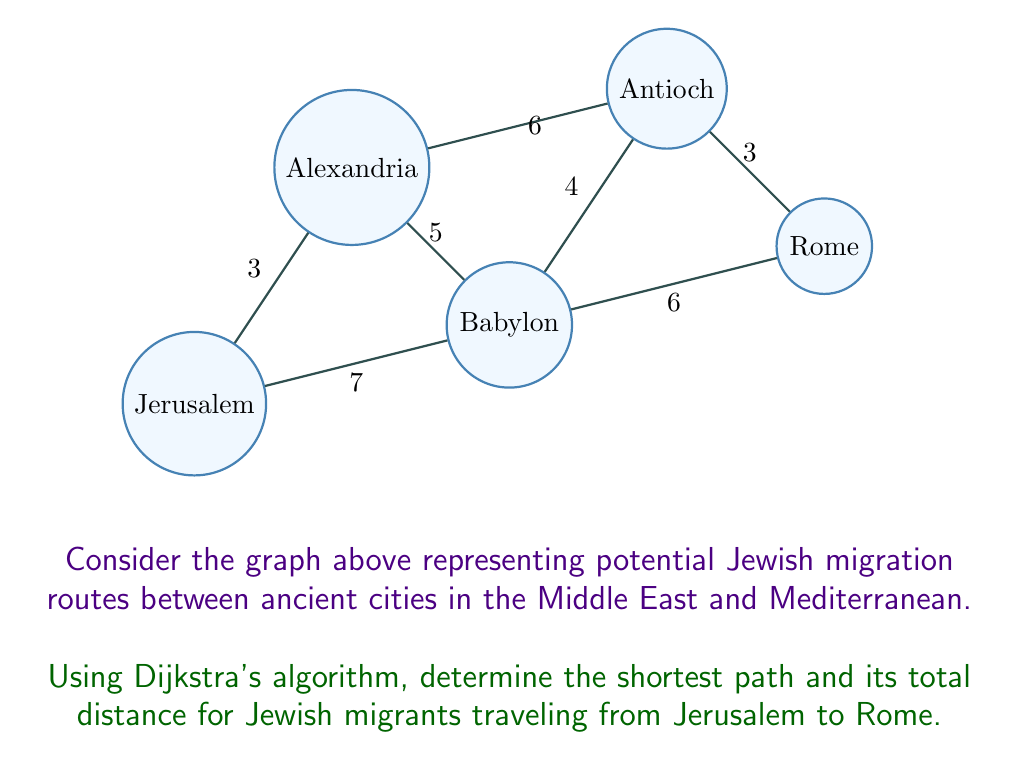Teach me how to tackle this problem. To solve this problem using Dijkstra's algorithm, we'll follow these steps:

1) Initialize:
   - Set distance to Jerusalem (start) as 0
   - Set distances to all other vertices as infinity
   - Set all vertices as unvisited

2) For the current vertex (starting with Jerusalem), consider all unvisited neighbors and calculate their tentative distances.
   
3) When we're done considering all neighbors of the current vertex, mark it as visited.

4) If Rome has been marked visited, we're done. Otherwise, select the unvisited vertex with the smallest tentative distance and set it as the new current vertex. Go back to step 2.

Let's apply the algorithm:

Start: Jerusalem (A)
- A to B: 3
- A to C: 7

Select B (shorter distance)
- B to D: 3 + 6 = 9
- B to C: 3 + 5 = 8 (shorter than direct A to C)

Select C
- C to D: 8 + 4 = 12 (shorter than via B)
- C to E: 8 + 6 = 14

Select D
- D to E: 12 + 3 = 15 (shorter than via C)

The shortest path is therefore Jerusalem (A) → Alexandria (B) → Babylon (C) → Antioch (D) → Rome (E).

The total distance is: 3 + 5 + 4 + 3 = 15.
Answer: Shortest path: Jerusalem → Alexandria → Babylon → Antioch → Rome; Distance: 15 